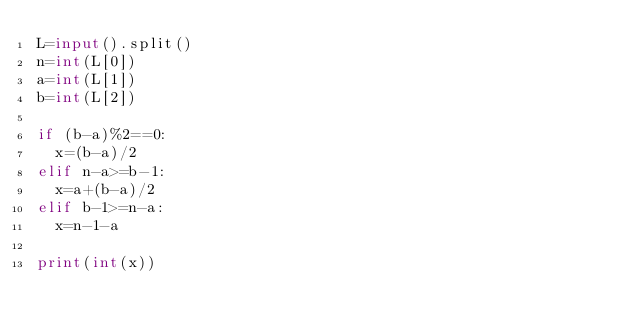<code> <loc_0><loc_0><loc_500><loc_500><_Python_>L=input().split()
n=int(L[0])
a=int(L[1])
b=int(L[2])
     
if (b-a)%2==0:
  x=(b-a)/2
elif n-a>=b-1:
  x=a+(b-a)/2
elif b-1>=n-a:
  x=n-1-a
     
print(int(x))</code> 